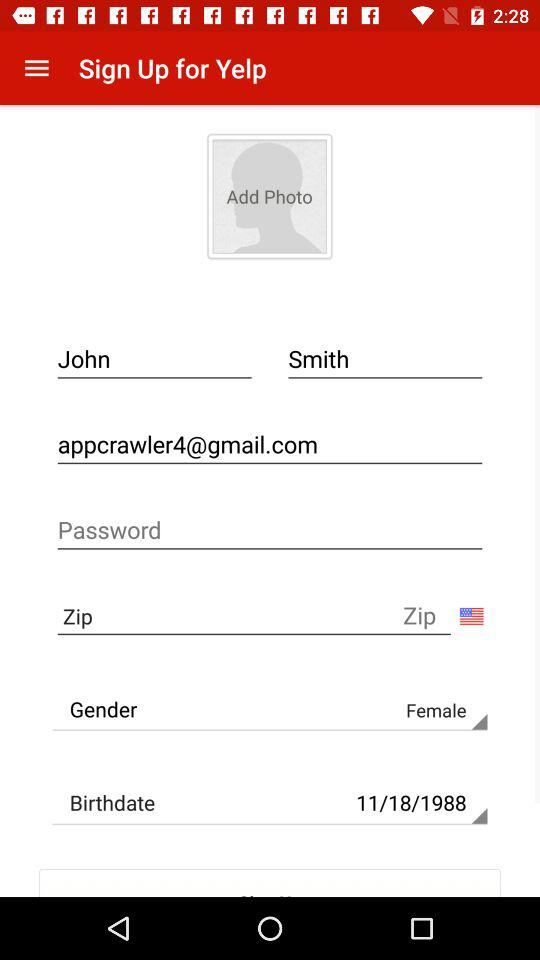How many text inputs are there for the first and last name field combined?
Answer the question using a single word or phrase. 2 